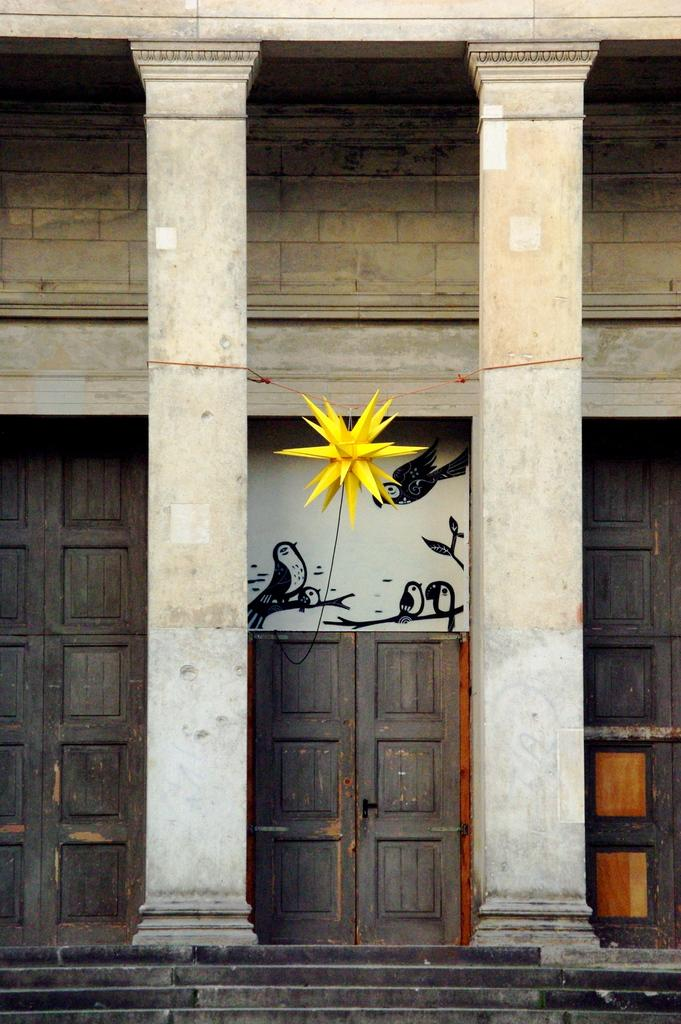What type of structure is visible in the image? There is a building in the image. What is the board used for in the image? The purpose of the board in the image is not specified, but it is present. Can you describe the object in the image? The description of the object in the image is not provided, but it is mentioned as being present. How many doors can be seen in the image? There are doors in the image, but the exact number is not specified. What architectural feature is present in the image? Pillars are present in the image. What is the purpose of the staircase in the image? The purpose of the staircase in the image is not specified, but it is mentioned as being present. What type of plantation is visible in the image? There is no plantation present in the image. What badge is the person wearing in the image? There is no person or badge visible in the image. 